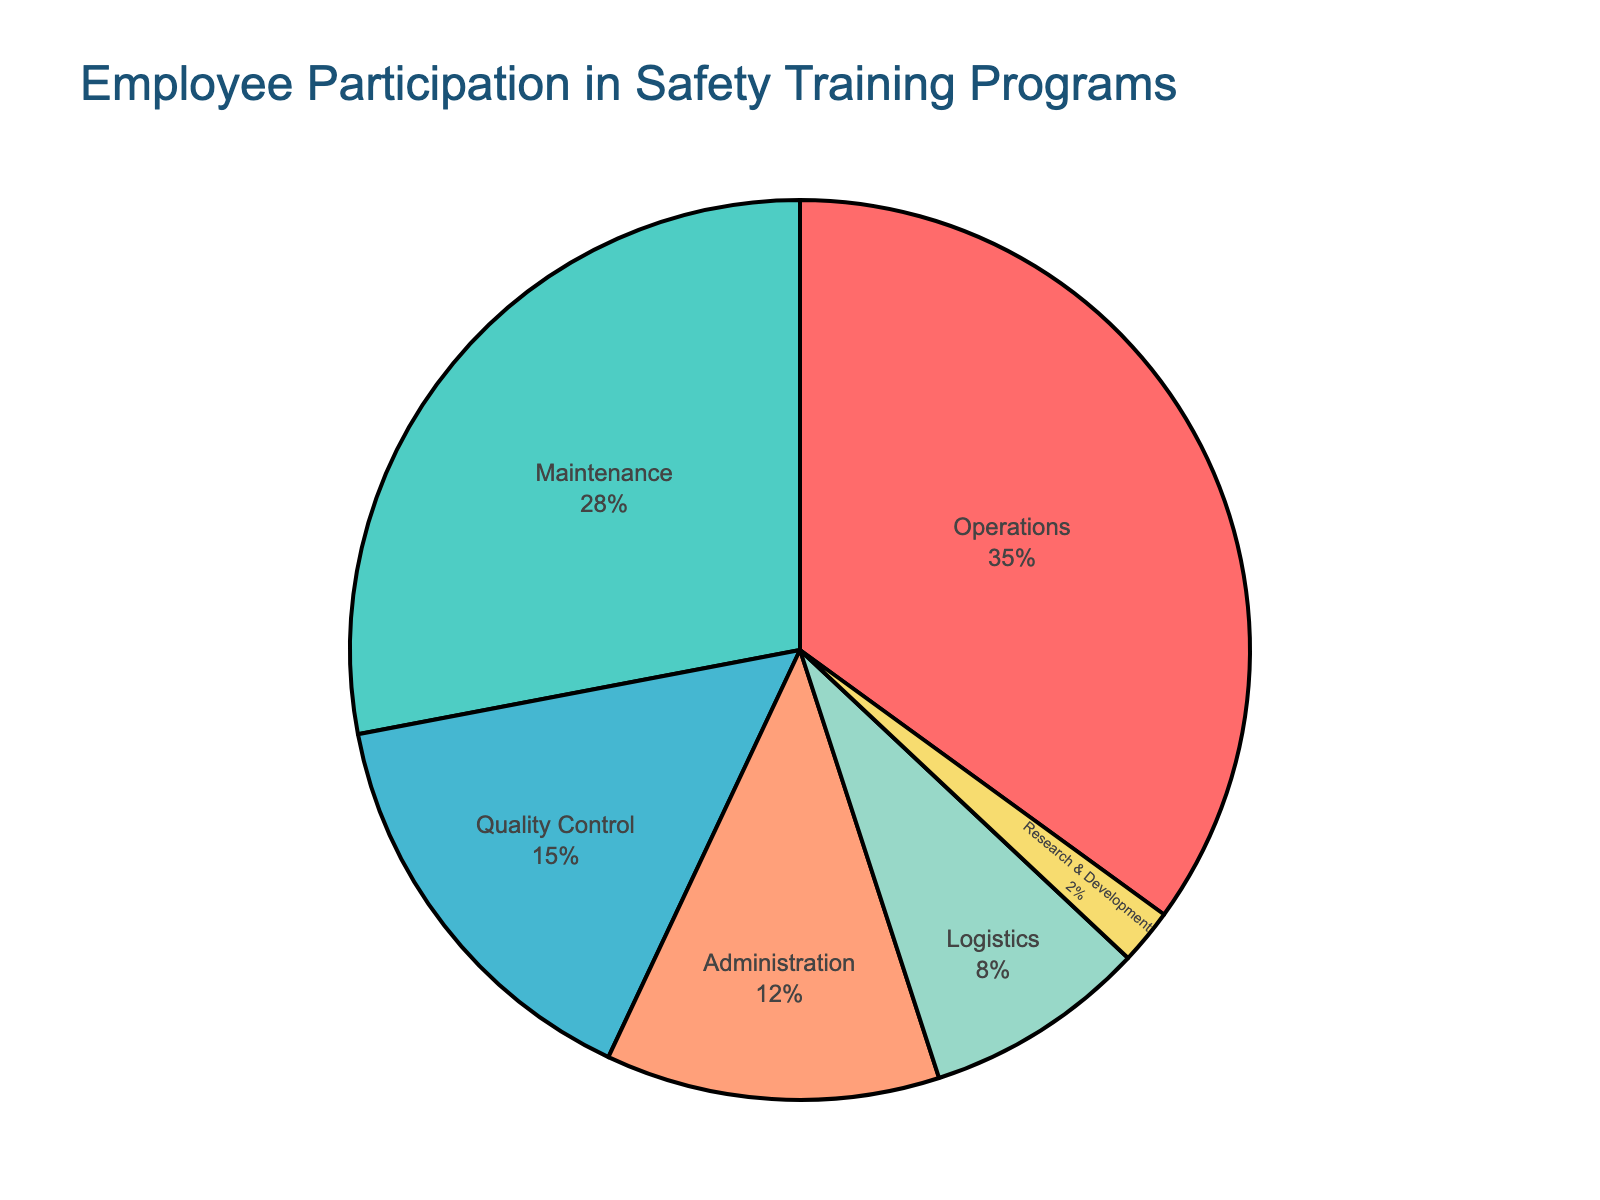What percentage of participation is from the Operations department? Look at the pie chart and identify the percentage label associated with the Operations department section.
Answer: 35% Which two departments combined have the highest participation rate? Identify the two sections of the pie chart with the largest slices and add their participation rates. Operations (35%) and Maintenance (28%) are the largest. Their combined rate is 35% + 28%.
Answer: Operations and Maintenance Is the participation rate of Maintenance more or less than double that of Administration? Compare the participation rate of Maintenance (28%) with double that of Administration (12% * 2 = 24%). 28% is greater than 24%.
Answer: More Which department has the lowest participation rate and what is it? Look for the smallest section in the pie chart and note the department and its percentage. The smallest section belongs to Research & Development.
Answer: Research & Development, 2% What is the difference in participation rates between Quality Control and Logistics? Subtract the participation rate of Logistics (8%) from that of Quality Control (15%). The difference is 15% - 8%.
Answer: 7% What is the average participation rate across all departments? Add all participation rates from the pie chart (35% + 28% + 12% + 15% + 8% + 2% = 100%) and divide by the number of departments (6). 100% / 6.
Answer: 16.67% Does Quality Control have a higher or lower participation rate than Administration? Compare the participation rates of Quality Control (15%) and Administration (12%).
Answer: Higher Which department's participation rate is closest to 10%? Identify the section of the pie chart with a rate closest to 10%. Logistics is closest with 8%.
Answer: Logistics What's the combined participation rate of departments involved in direct operations (Operations, Maintenance, and Logistics)? Sum the participation rates of Operations (35%), Maintenance (28%), and Logistics (8%). 35% + 28% + 8%.
Answer: 71% Which color represents the Maintenance department on the pie chart? Look at the pie chart and identify the color section labeled Maintenance.
Answer: Green 